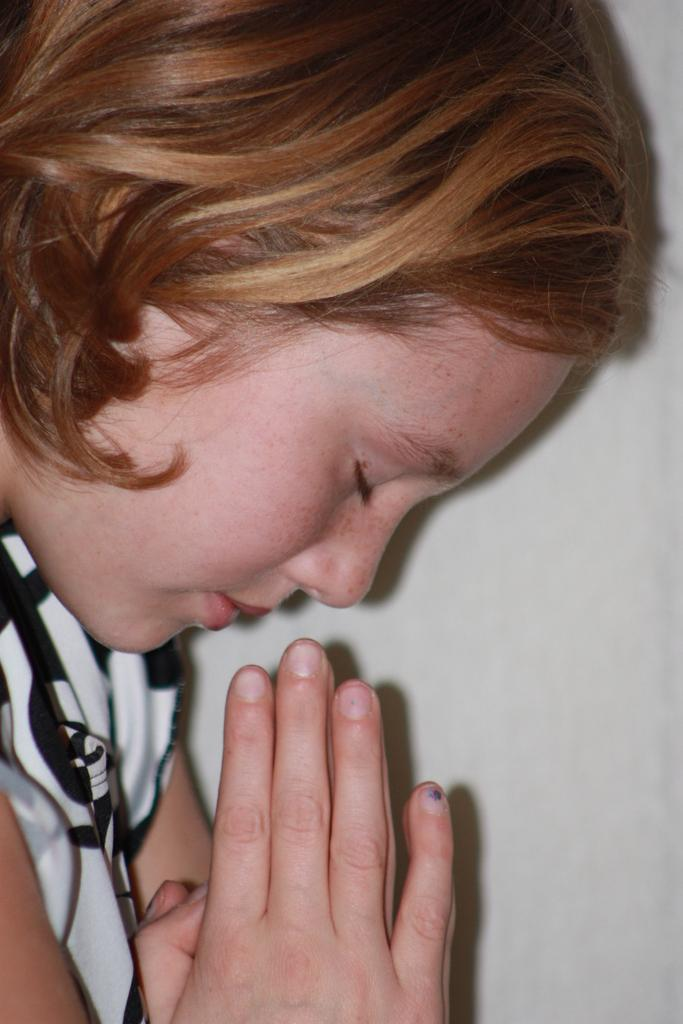Who is the main subject in the image? There is a girl in the image. What is the girl doing in the image? The girl is praying. What can be seen in the background of the image? There is a wall in the background of the image. What type of thread is being used by the girl to talk to her friends in the image? There is no thread or friends present in the image; the girl is praying. 